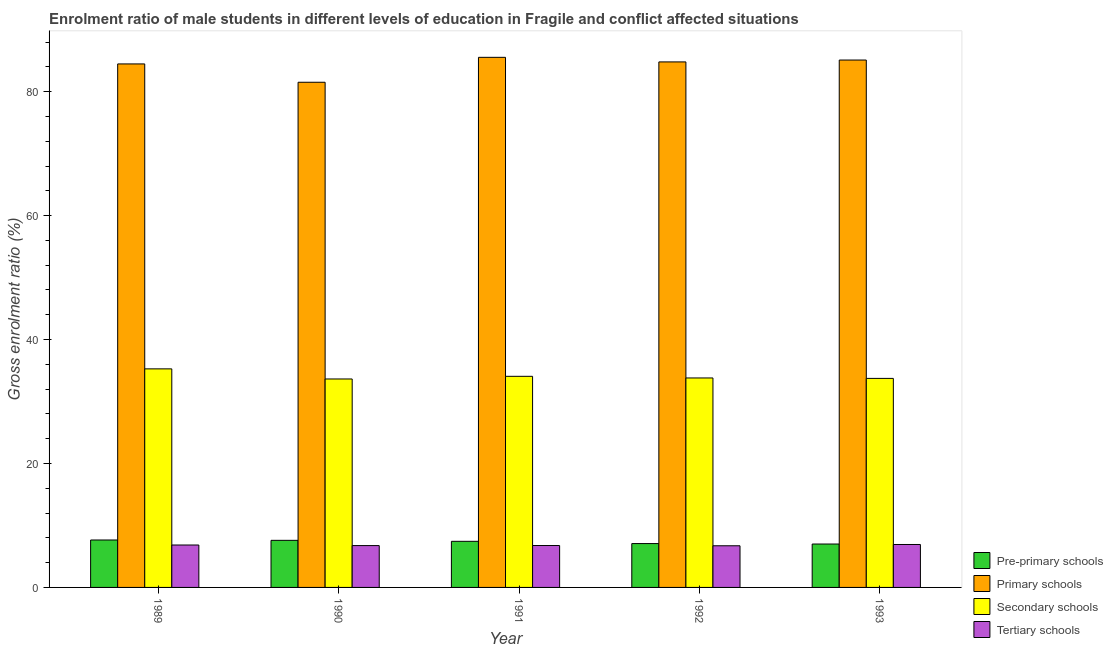How many different coloured bars are there?
Ensure brevity in your answer.  4. How many groups of bars are there?
Your answer should be compact. 5. Are the number of bars per tick equal to the number of legend labels?
Make the answer very short. Yes. Are the number of bars on each tick of the X-axis equal?
Make the answer very short. Yes. How many bars are there on the 2nd tick from the left?
Offer a terse response. 4. How many bars are there on the 1st tick from the right?
Your answer should be compact. 4. What is the label of the 4th group of bars from the left?
Provide a short and direct response. 1992. What is the gross enrolment ratio(female) in secondary schools in 1990?
Give a very brief answer. 33.64. Across all years, what is the maximum gross enrolment ratio(female) in pre-primary schools?
Your response must be concise. 7.65. Across all years, what is the minimum gross enrolment ratio(female) in primary schools?
Make the answer very short. 81.51. What is the total gross enrolment ratio(female) in primary schools in the graph?
Your answer should be very brief. 421.42. What is the difference between the gross enrolment ratio(female) in secondary schools in 1991 and that in 1992?
Offer a terse response. 0.26. What is the difference between the gross enrolment ratio(female) in secondary schools in 1992 and the gross enrolment ratio(female) in pre-primary schools in 1990?
Keep it short and to the point. 0.16. What is the average gross enrolment ratio(female) in secondary schools per year?
Offer a terse response. 34.1. What is the ratio of the gross enrolment ratio(female) in primary schools in 1990 to that in 1991?
Provide a succinct answer. 0.95. Is the gross enrolment ratio(female) in primary schools in 1990 less than that in 1992?
Ensure brevity in your answer.  Yes. What is the difference between the highest and the second highest gross enrolment ratio(female) in tertiary schools?
Your answer should be very brief. 0.08. What is the difference between the highest and the lowest gross enrolment ratio(female) in pre-primary schools?
Keep it short and to the point. 0.65. In how many years, is the gross enrolment ratio(female) in tertiary schools greater than the average gross enrolment ratio(female) in tertiary schools taken over all years?
Your response must be concise. 2. What does the 2nd bar from the left in 1992 represents?
Give a very brief answer. Primary schools. What does the 1st bar from the right in 1991 represents?
Keep it short and to the point. Tertiary schools. How many bars are there?
Give a very brief answer. 20. Are all the bars in the graph horizontal?
Provide a short and direct response. No. Does the graph contain any zero values?
Provide a succinct answer. No. Does the graph contain grids?
Provide a short and direct response. No. Where does the legend appear in the graph?
Offer a terse response. Bottom right. What is the title of the graph?
Your answer should be very brief. Enrolment ratio of male students in different levels of education in Fragile and conflict affected situations. What is the Gross enrolment ratio (%) of Pre-primary schools in 1989?
Your answer should be compact. 7.65. What is the Gross enrolment ratio (%) in Primary schools in 1989?
Your answer should be very brief. 84.47. What is the Gross enrolment ratio (%) in Secondary schools in 1989?
Ensure brevity in your answer.  35.27. What is the Gross enrolment ratio (%) of Tertiary schools in 1989?
Give a very brief answer. 6.84. What is the Gross enrolment ratio (%) in Pre-primary schools in 1990?
Give a very brief answer. 7.6. What is the Gross enrolment ratio (%) in Primary schools in 1990?
Offer a very short reply. 81.51. What is the Gross enrolment ratio (%) of Secondary schools in 1990?
Provide a succinct answer. 33.64. What is the Gross enrolment ratio (%) of Tertiary schools in 1990?
Offer a terse response. 6.75. What is the Gross enrolment ratio (%) of Pre-primary schools in 1991?
Provide a short and direct response. 7.44. What is the Gross enrolment ratio (%) in Primary schools in 1991?
Your answer should be compact. 85.54. What is the Gross enrolment ratio (%) of Secondary schools in 1991?
Make the answer very short. 34.06. What is the Gross enrolment ratio (%) of Tertiary schools in 1991?
Give a very brief answer. 6.76. What is the Gross enrolment ratio (%) of Pre-primary schools in 1992?
Offer a terse response. 7.08. What is the Gross enrolment ratio (%) in Primary schools in 1992?
Offer a terse response. 84.8. What is the Gross enrolment ratio (%) in Secondary schools in 1992?
Make the answer very short. 33.8. What is the Gross enrolment ratio (%) of Tertiary schools in 1992?
Provide a succinct answer. 6.72. What is the Gross enrolment ratio (%) in Pre-primary schools in 1993?
Your answer should be compact. 7. What is the Gross enrolment ratio (%) of Primary schools in 1993?
Give a very brief answer. 85.1. What is the Gross enrolment ratio (%) of Secondary schools in 1993?
Your response must be concise. 33.73. What is the Gross enrolment ratio (%) in Tertiary schools in 1993?
Your answer should be compact. 6.93. Across all years, what is the maximum Gross enrolment ratio (%) in Pre-primary schools?
Provide a succinct answer. 7.65. Across all years, what is the maximum Gross enrolment ratio (%) of Primary schools?
Make the answer very short. 85.54. Across all years, what is the maximum Gross enrolment ratio (%) in Secondary schools?
Make the answer very short. 35.27. Across all years, what is the maximum Gross enrolment ratio (%) in Tertiary schools?
Your response must be concise. 6.93. Across all years, what is the minimum Gross enrolment ratio (%) of Pre-primary schools?
Offer a very short reply. 7. Across all years, what is the minimum Gross enrolment ratio (%) of Primary schools?
Keep it short and to the point. 81.51. Across all years, what is the minimum Gross enrolment ratio (%) in Secondary schools?
Your answer should be compact. 33.64. Across all years, what is the minimum Gross enrolment ratio (%) in Tertiary schools?
Offer a terse response. 6.72. What is the total Gross enrolment ratio (%) in Pre-primary schools in the graph?
Your response must be concise. 36.77. What is the total Gross enrolment ratio (%) of Primary schools in the graph?
Offer a very short reply. 421.42. What is the total Gross enrolment ratio (%) of Secondary schools in the graph?
Offer a very short reply. 170.49. What is the total Gross enrolment ratio (%) in Tertiary schools in the graph?
Offer a very short reply. 34.01. What is the difference between the Gross enrolment ratio (%) in Pre-primary schools in 1989 and that in 1990?
Ensure brevity in your answer.  0.05. What is the difference between the Gross enrolment ratio (%) of Primary schools in 1989 and that in 1990?
Your answer should be very brief. 2.96. What is the difference between the Gross enrolment ratio (%) of Secondary schools in 1989 and that in 1990?
Provide a short and direct response. 1.63. What is the difference between the Gross enrolment ratio (%) in Tertiary schools in 1989 and that in 1990?
Offer a terse response. 0.09. What is the difference between the Gross enrolment ratio (%) of Pre-primary schools in 1989 and that in 1991?
Offer a very short reply. 0.22. What is the difference between the Gross enrolment ratio (%) in Primary schools in 1989 and that in 1991?
Provide a succinct answer. -1.06. What is the difference between the Gross enrolment ratio (%) of Secondary schools in 1989 and that in 1991?
Keep it short and to the point. 1.2. What is the difference between the Gross enrolment ratio (%) in Tertiary schools in 1989 and that in 1991?
Offer a very short reply. 0.08. What is the difference between the Gross enrolment ratio (%) of Pre-primary schools in 1989 and that in 1992?
Your response must be concise. 0.58. What is the difference between the Gross enrolment ratio (%) in Primary schools in 1989 and that in 1992?
Your response must be concise. -0.33. What is the difference between the Gross enrolment ratio (%) in Secondary schools in 1989 and that in 1992?
Offer a terse response. 1.47. What is the difference between the Gross enrolment ratio (%) in Tertiary schools in 1989 and that in 1992?
Your response must be concise. 0.12. What is the difference between the Gross enrolment ratio (%) of Pre-primary schools in 1989 and that in 1993?
Make the answer very short. 0.65. What is the difference between the Gross enrolment ratio (%) of Primary schools in 1989 and that in 1993?
Provide a short and direct response. -0.63. What is the difference between the Gross enrolment ratio (%) in Secondary schools in 1989 and that in 1993?
Give a very brief answer. 1.54. What is the difference between the Gross enrolment ratio (%) in Tertiary schools in 1989 and that in 1993?
Your answer should be very brief. -0.08. What is the difference between the Gross enrolment ratio (%) in Pre-primary schools in 1990 and that in 1991?
Keep it short and to the point. 0.16. What is the difference between the Gross enrolment ratio (%) of Primary schools in 1990 and that in 1991?
Provide a short and direct response. -4.02. What is the difference between the Gross enrolment ratio (%) in Secondary schools in 1990 and that in 1991?
Provide a short and direct response. -0.43. What is the difference between the Gross enrolment ratio (%) of Tertiary schools in 1990 and that in 1991?
Offer a terse response. -0.01. What is the difference between the Gross enrolment ratio (%) in Pre-primary schools in 1990 and that in 1992?
Ensure brevity in your answer.  0.52. What is the difference between the Gross enrolment ratio (%) in Primary schools in 1990 and that in 1992?
Ensure brevity in your answer.  -3.28. What is the difference between the Gross enrolment ratio (%) of Secondary schools in 1990 and that in 1992?
Provide a succinct answer. -0.16. What is the difference between the Gross enrolment ratio (%) in Tertiary schools in 1990 and that in 1992?
Your answer should be compact. 0.03. What is the difference between the Gross enrolment ratio (%) in Pre-primary schools in 1990 and that in 1993?
Make the answer very short. 0.6. What is the difference between the Gross enrolment ratio (%) of Primary schools in 1990 and that in 1993?
Provide a succinct answer. -3.58. What is the difference between the Gross enrolment ratio (%) in Secondary schools in 1990 and that in 1993?
Offer a terse response. -0.09. What is the difference between the Gross enrolment ratio (%) of Tertiary schools in 1990 and that in 1993?
Keep it short and to the point. -0.17. What is the difference between the Gross enrolment ratio (%) of Pre-primary schools in 1991 and that in 1992?
Keep it short and to the point. 0.36. What is the difference between the Gross enrolment ratio (%) of Primary schools in 1991 and that in 1992?
Keep it short and to the point. 0.74. What is the difference between the Gross enrolment ratio (%) of Secondary schools in 1991 and that in 1992?
Provide a short and direct response. 0.26. What is the difference between the Gross enrolment ratio (%) of Tertiary schools in 1991 and that in 1992?
Keep it short and to the point. 0.04. What is the difference between the Gross enrolment ratio (%) in Pre-primary schools in 1991 and that in 1993?
Provide a succinct answer. 0.44. What is the difference between the Gross enrolment ratio (%) in Primary schools in 1991 and that in 1993?
Your answer should be compact. 0.44. What is the difference between the Gross enrolment ratio (%) of Secondary schools in 1991 and that in 1993?
Your answer should be very brief. 0.34. What is the difference between the Gross enrolment ratio (%) in Tertiary schools in 1991 and that in 1993?
Offer a terse response. -0.17. What is the difference between the Gross enrolment ratio (%) of Pre-primary schools in 1992 and that in 1993?
Ensure brevity in your answer.  0.07. What is the difference between the Gross enrolment ratio (%) of Primary schools in 1992 and that in 1993?
Keep it short and to the point. -0.3. What is the difference between the Gross enrolment ratio (%) of Secondary schools in 1992 and that in 1993?
Keep it short and to the point. 0.07. What is the difference between the Gross enrolment ratio (%) in Tertiary schools in 1992 and that in 1993?
Provide a short and direct response. -0.21. What is the difference between the Gross enrolment ratio (%) in Pre-primary schools in 1989 and the Gross enrolment ratio (%) in Primary schools in 1990?
Your answer should be compact. -73.86. What is the difference between the Gross enrolment ratio (%) of Pre-primary schools in 1989 and the Gross enrolment ratio (%) of Secondary schools in 1990?
Your answer should be very brief. -25.98. What is the difference between the Gross enrolment ratio (%) of Pre-primary schools in 1989 and the Gross enrolment ratio (%) of Tertiary schools in 1990?
Offer a very short reply. 0.9. What is the difference between the Gross enrolment ratio (%) in Primary schools in 1989 and the Gross enrolment ratio (%) in Secondary schools in 1990?
Ensure brevity in your answer.  50.84. What is the difference between the Gross enrolment ratio (%) in Primary schools in 1989 and the Gross enrolment ratio (%) in Tertiary schools in 1990?
Ensure brevity in your answer.  77.72. What is the difference between the Gross enrolment ratio (%) of Secondary schools in 1989 and the Gross enrolment ratio (%) of Tertiary schools in 1990?
Ensure brevity in your answer.  28.51. What is the difference between the Gross enrolment ratio (%) in Pre-primary schools in 1989 and the Gross enrolment ratio (%) in Primary schools in 1991?
Make the answer very short. -77.88. What is the difference between the Gross enrolment ratio (%) in Pre-primary schools in 1989 and the Gross enrolment ratio (%) in Secondary schools in 1991?
Ensure brevity in your answer.  -26.41. What is the difference between the Gross enrolment ratio (%) in Pre-primary schools in 1989 and the Gross enrolment ratio (%) in Tertiary schools in 1991?
Your response must be concise. 0.89. What is the difference between the Gross enrolment ratio (%) of Primary schools in 1989 and the Gross enrolment ratio (%) of Secondary schools in 1991?
Offer a terse response. 50.41. What is the difference between the Gross enrolment ratio (%) of Primary schools in 1989 and the Gross enrolment ratio (%) of Tertiary schools in 1991?
Offer a terse response. 77.71. What is the difference between the Gross enrolment ratio (%) in Secondary schools in 1989 and the Gross enrolment ratio (%) in Tertiary schools in 1991?
Provide a short and direct response. 28.5. What is the difference between the Gross enrolment ratio (%) of Pre-primary schools in 1989 and the Gross enrolment ratio (%) of Primary schools in 1992?
Your answer should be compact. -77.14. What is the difference between the Gross enrolment ratio (%) in Pre-primary schools in 1989 and the Gross enrolment ratio (%) in Secondary schools in 1992?
Provide a succinct answer. -26.15. What is the difference between the Gross enrolment ratio (%) in Pre-primary schools in 1989 and the Gross enrolment ratio (%) in Tertiary schools in 1992?
Give a very brief answer. 0.93. What is the difference between the Gross enrolment ratio (%) in Primary schools in 1989 and the Gross enrolment ratio (%) in Secondary schools in 1992?
Give a very brief answer. 50.67. What is the difference between the Gross enrolment ratio (%) in Primary schools in 1989 and the Gross enrolment ratio (%) in Tertiary schools in 1992?
Offer a terse response. 77.75. What is the difference between the Gross enrolment ratio (%) of Secondary schools in 1989 and the Gross enrolment ratio (%) of Tertiary schools in 1992?
Give a very brief answer. 28.55. What is the difference between the Gross enrolment ratio (%) in Pre-primary schools in 1989 and the Gross enrolment ratio (%) in Primary schools in 1993?
Offer a terse response. -77.44. What is the difference between the Gross enrolment ratio (%) in Pre-primary schools in 1989 and the Gross enrolment ratio (%) in Secondary schools in 1993?
Provide a short and direct response. -26.07. What is the difference between the Gross enrolment ratio (%) of Pre-primary schools in 1989 and the Gross enrolment ratio (%) of Tertiary schools in 1993?
Your answer should be compact. 0.73. What is the difference between the Gross enrolment ratio (%) of Primary schools in 1989 and the Gross enrolment ratio (%) of Secondary schools in 1993?
Provide a succinct answer. 50.74. What is the difference between the Gross enrolment ratio (%) in Primary schools in 1989 and the Gross enrolment ratio (%) in Tertiary schools in 1993?
Make the answer very short. 77.54. What is the difference between the Gross enrolment ratio (%) of Secondary schools in 1989 and the Gross enrolment ratio (%) of Tertiary schools in 1993?
Your answer should be very brief. 28.34. What is the difference between the Gross enrolment ratio (%) in Pre-primary schools in 1990 and the Gross enrolment ratio (%) in Primary schools in 1991?
Offer a very short reply. -77.94. What is the difference between the Gross enrolment ratio (%) of Pre-primary schools in 1990 and the Gross enrolment ratio (%) of Secondary schools in 1991?
Keep it short and to the point. -26.46. What is the difference between the Gross enrolment ratio (%) in Pre-primary schools in 1990 and the Gross enrolment ratio (%) in Tertiary schools in 1991?
Offer a terse response. 0.84. What is the difference between the Gross enrolment ratio (%) of Primary schools in 1990 and the Gross enrolment ratio (%) of Secondary schools in 1991?
Ensure brevity in your answer.  47.45. What is the difference between the Gross enrolment ratio (%) of Primary schools in 1990 and the Gross enrolment ratio (%) of Tertiary schools in 1991?
Make the answer very short. 74.75. What is the difference between the Gross enrolment ratio (%) in Secondary schools in 1990 and the Gross enrolment ratio (%) in Tertiary schools in 1991?
Ensure brevity in your answer.  26.87. What is the difference between the Gross enrolment ratio (%) of Pre-primary schools in 1990 and the Gross enrolment ratio (%) of Primary schools in 1992?
Make the answer very short. -77.2. What is the difference between the Gross enrolment ratio (%) of Pre-primary schools in 1990 and the Gross enrolment ratio (%) of Secondary schools in 1992?
Your answer should be compact. -26.2. What is the difference between the Gross enrolment ratio (%) of Pre-primary schools in 1990 and the Gross enrolment ratio (%) of Tertiary schools in 1992?
Your response must be concise. 0.88. What is the difference between the Gross enrolment ratio (%) of Primary schools in 1990 and the Gross enrolment ratio (%) of Secondary schools in 1992?
Provide a short and direct response. 47.71. What is the difference between the Gross enrolment ratio (%) in Primary schools in 1990 and the Gross enrolment ratio (%) in Tertiary schools in 1992?
Give a very brief answer. 74.79. What is the difference between the Gross enrolment ratio (%) in Secondary schools in 1990 and the Gross enrolment ratio (%) in Tertiary schools in 1992?
Offer a very short reply. 26.92. What is the difference between the Gross enrolment ratio (%) of Pre-primary schools in 1990 and the Gross enrolment ratio (%) of Primary schools in 1993?
Give a very brief answer. -77.5. What is the difference between the Gross enrolment ratio (%) of Pre-primary schools in 1990 and the Gross enrolment ratio (%) of Secondary schools in 1993?
Your answer should be compact. -26.13. What is the difference between the Gross enrolment ratio (%) in Pre-primary schools in 1990 and the Gross enrolment ratio (%) in Tertiary schools in 1993?
Provide a succinct answer. 0.67. What is the difference between the Gross enrolment ratio (%) of Primary schools in 1990 and the Gross enrolment ratio (%) of Secondary schools in 1993?
Ensure brevity in your answer.  47.79. What is the difference between the Gross enrolment ratio (%) of Primary schools in 1990 and the Gross enrolment ratio (%) of Tertiary schools in 1993?
Offer a terse response. 74.59. What is the difference between the Gross enrolment ratio (%) in Secondary schools in 1990 and the Gross enrolment ratio (%) in Tertiary schools in 1993?
Ensure brevity in your answer.  26.71. What is the difference between the Gross enrolment ratio (%) in Pre-primary schools in 1991 and the Gross enrolment ratio (%) in Primary schools in 1992?
Your response must be concise. -77.36. What is the difference between the Gross enrolment ratio (%) of Pre-primary schools in 1991 and the Gross enrolment ratio (%) of Secondary schools in 1992?
Your answer should be compact. -26.36. What is the difference between the Gross enrolment ratio (%) in Pre-primary schools in 1991 and the Gross enrolment ratio (%) in Tertiary schools in 1992?
Give a very brief answer. 0.72. What is the difference between the Gross enrolment ratio (%) in Primary schools in 1991 and the Gross enrolment ratio (%) in Secondary schools in 1992?
Ensure brevity in your answer.  51.74. What is the difference between the Gross enrolment ratio (%) in Primary schools in 1991 and the Gross enrolment ratio (%) in Tertiary schools in 1992?
Give a very brief answer. 78.82. What is the difference between the Gross enrolment ratio (%) in Secondary schools in 1991 and the Gross enrolment ratio (%) in Tertiary schools in 1992?
Offer a very short reply. 27.34. What is the difference between the Gross enrolment ratio (%) of Pre-primary schools in 1991 and the Gross enrolment ratio (%) of Primary schools in 1993?
Provide a succinct answer. -77.66. What is the difference between the Gross enrolment ratio (%) in Pre-primary schools in 1991 and the Gross enrolment ratio (%) in Secondary schools in 1993?
Your response must be concise. -26.29. What is the difference between the Gross enrolment ratio (%) in Pre-primary schools in 1991 and the Gross enrolment ratio (%) in Tertiary schools in 1993?
Offer a very short reply. 0.51. What is the difference between the Gross enrolment ratio (%) of Primary schools in 1991 and the Gross enrolment ratio (%) of Secondary schools in 1993?
Provide a succinct answer. 51.81. What is the difference between the Gross enrolment ratio (%) in Primary schools in 1991 and the Gross enrolment ratio (%) in Tertiary schools in 1993?
Provide a short and direct response. 78.61. What is the difference between the Gross enrolment ratio (%) in Secondary schools in 1991 and the Gross enrolment ratio (%) in Tertiary schools in 1993?
Keep it short and to the point. 27.14. What is the difference between the Gross enrolment ratio (%) of Pre-primary schools in 1992 and the Gross enrolment ratio (%) of Primary schools in 1993?
Offer a very short reply. -78.02. What is the difference between the Gross enrolment ratio (%) of Pre-primary schools in 1992 and the Gross enrolment ratio (%) of Secondary schools in 1993?
Offer a terse response. -26.65. What is the difference between the Gross enrolment ratio (%) of Pre-primary schools in 1992 and the Gross enrolment ratio (%) of Tertiary schools in 1993?
Your answer should be compact. 0.15. What is the difference between the Gross enrolment ratio (%) of Primary schools in 1992 and the Gross enrolment ratio (%) of Secondary schools in 1993?
Your answer should be very brief. 51.07. What is the difference between the Gross enrolment ratio (%) in Primary schools in 1992 and the Gross enrolment ratio (%) in Tertiary schools in 1993?
Offer a terse response. 77.87. What is the difference between the Gross enrolment ratio (%) in Secondary schools in 1992 and the Gross enrolment ratio (%) in Tertiary schools in 1993?
Provide a short and direct response. 26.87. What is the average Gross enrolment ratio (%) of Pre-primary schools per year?
Provide a succinct answer. 7.35. What is the average Gross enrolment ratio (%) in Primary schools per year?
Provide a short and direct response. 84.28. What is the average Gross enrolment ratio (%) in Secondary schools per year?
Your response must be concise. 34.1. What is the average Gross enrolment ratio (%) of Tertiary schools per year?
Provide a short and direct response. 6.8. In the year 1989, what is the difference between the Gross enrolment ratio (%) of Pre-primary schools and Gross enrolment ratio (%) of Primary schools?
Provide a short and direct response. -76.82. In the year 1989, what is the difference between the Gross enrolment ratio (%) in Pre-primary schools and Gross enrolment ratio (%) in Secondary schools?
Your answer should be compact. -27.61. In the year 1989, what is the difference between the Gross enrolment ratio (%) in Pre-primary schools and Gross enrolment ratio (%) in Tertiary schools?
Keep it short and to the point. 0.81. In the year 1989, what is the difference between the Gross enrolment ratio (%) in Primary schools and Gross enrolment ratio (%) in Secondary schools?
Make the answer very short. 49.21. In the year 1989, what is the difference between the Gross enrolment ratio (%) in Primary schools and Gross enrolment ratio (%) in Tertiary schools?
Ensure brevity in your answer.  77.63. In the year 1989, what is the difference between the Gross enrolment ratio (%) in Secondary schools and Gross enrolment ratio (%) in Tertiary schools?
Your response must be concise. 28.42. In the year 1990, what is the difference between the Gross enrolment ratio (%) in Pre-primary schools and Gross enrolment ratio (%) in Primary schools?
Provide a succinct answer. -73.91. In the year 1990, what is the difference between the Gross enrolment ratio (%) in Pre-primary schools and Gross enrolment ratio (%) in Secondary schools?
Provide a short and direct response. -26.04. In the year 1990, what is the difference between the Gross enrolment ratio (%) in Pre-primary schools and Gross enrolment ratio (%) in Tertiary schools?
Ensure brevity in your answer.  0.85. In the year 1990, what is the difference between the Gross enrolment ratio (%) of Primary schools and Gross enrolment ratio (%) of Secondary schools?
Provide a succinct answer. 47.88. In the year 1990, what is the difference between the Gross enrolment ratio (%) in Primary schools and Gross enrolment ratio (%) in Tertiary schools?
Offer a terse response. 74.76. In the year 1990, what is the difference between the Gross enrolment ratio (%) in Secondary schools and Gross enrolment ratio (%) in Tertiary schools?
Provide a short and direct response. 26.88. In the year 1991, what is the difference between the Gross enrolment ratio (%) in Pre-primary schools and Gross enrolment ratio (%) in Primary schools?
Make the answer very short. -78.1. In the year 1991, what is the difference between the Gross enrolment ratio (%) of Pre-primary schools and Gross enrolment ratio (%) of Secondary schools?
Ensure brevity in your answer.  -26.63. In the year 1991, what is the difference between the Gross enrolment ratio (%) in Pre-primary schools and Gross enrolment ratio (%) in Tertiary schools?
Ensure brevity in your answer.  0.68. In the year 1991, what is the difference between the Gross enrolment ratio (%) in Primary schools and Gross enrolment ratio (%) in Secondary schools?
Make the answer very short. 51.47. In the year 1991, what is the difference between the Gross enrolment ratio (%) of Primary schools and Gross enrolment ratio (%) of Tertiary schools?
Ensure brevity in your answer.  78.77. In the year 1991, what is the difference between the Gross enrolment ratio (%) of Secondary schools and Gross enrolment ratio (%) of Tertiary schools?
Your answer should be compact. 27.3. In the year 1992, what is the difference between the Gross enrolment ratio (%) of Pre-primary schools and Gross enrolment ratio (%) of Primary schools?
Provide a short and direct response. -77.72. In the year 1992, what is the difference between the Gross enrolment ratio (%) of Pre-primary schools and Gross enrolment ratio (%) of Secondary schools?
Your answer should be compact. -26.72. In the year 1992, what is the difference between the Gross enrolment ratio (%) of Pre-primary schools and Gross enrolment ratio (%) of Tertiary schools?
Your response must be concise. 0.36. In the year 1992, what is the difference between the Gross enrolment ratio (%) of Primary schools and Gross enrolment ratio (%) of Secondary schools?
Provide a short and direct response. 51. In the year 1992, what is the difference between the Gross enrolment ratio (%) in Primary schools and Gross enrolment ratio (%) in Tertiary schools?
Your answer should be compact. 78.08. In the year 1992, what is the difference between the Gross enrolment ratio (%) in Secondary schools and Gross enrolment ratio (%) in Tertiary schools?
Ensure brevity in your answer.  27.08. In the year 1993, what is the difference between the Gross enrolment ratio (%) of Pre-primary schools and Gross enrolment ratio (%) of Primary schools?
Offer a very short reply. -78.09. In the year 1993, what is the difference between the Gross enrolment ratio (%) of Pre-primary schools and Gross enrolment ratio (%) of Secondary schools?
Your answer should be very brief. -26.73. In the year 1993, what is the difference between the Gross enrolment ratio (%) in Pre-primary schools and Gross enrolment ratio (%) in Tertiary schools?
Your answer should be compact. 0.08. In the year 1993, what is the difference between the Gross enrolment ratio (%) of Primary schools and Gross enrolment ratio (%) of Secondary schools?
Ensure brevity in your answer.  51.37. In the year 1993, what is the difference between the Gross enrolment ratio (%) in Primary schools and Gross enrolment ratio (%) in Tertiary schools?
Your response must be concise. 78.17. In the year 1993, what is the difference between the Gross enrolment ratio (%) of Secondary schools and Gross enrolment ratio (%) of Tertiary schools?
Keep it short and to the point. 26.8. What is the ratio of the Gross enrolment ratio (%) in Pre-primary schools in 1989 to that in 1990?
Make the answer very short. 1.01. What is the ratio of the Gross enrolment ratio (%) in Primary schools in 1989 to that in 1990?
Your answer should be compact. 1.04. What is the ratio of the Gross enrolment ratio (%) of Secondary schools in 1989 to that in 1990?
Provide a succinct answer. 1.05. What is the ratio of the Gross enrolment ratio (%) of Tertiary schools in 1989 to that in 1990?
Your answer should be very brief. 1.01. What is the ratio of the Gross enrolment ratio (%) in Pre-primary schools in 1989 to that in 1991?
Ensure brevity in your answer.  1.03. What is the ratio of the Gross enrolment ratio (%) of Primary schools in 1989 to that in 1991?
Offer a terse response. 0.99. What is the ratio of the Gross enrolment ratio (%) in Secondary schools in 1989 to that in 1991?
Offer a terse response. 1.04. What is the ratio of the Gross enrolment ratio (%) of Tertiary schools in 1989 to that in 1991?
Offer a very short reply. 1.01. What is the ratio of the Gross enrolment ratio (%) in Pre-primary schools in 1989 to that in 1992?
Give a very brief answer. 1.08. What is the ratio of the Gross enrolment ratio (%) in Secondary schools in 1989 to that in 1992?
Offer a very short reply. 1.04. What is the ratio of the Gross enrolment ratio (%) of Tertiary schools in 1989 to that in 1992?
Your answer should be very brief. 1.02. What is the ratio of the Gross enrolment ratio (%) of Pre-primary schools in 1989 to that in 1993?
Your response must be concise. 1.09. What is the ratio of the Gross enrolment ratio (%) in Secondary schools in 1989 to that in 1993?
Your response must be concise. 1.05. What is the ratio of the Gross enrolment ratio (%) in Tertiary schools in 1989 to that in 1993?
Give a very brief answer. 0.99. What is the ratio of the Gross enrolment ratio (%) of Pre-primary schools in 1990 to that in 1991?
Provide a short and direct response. 1.02. What is the ratio of the Gross enrolment ratio (%) of Primary schools in 1990 to that in 1991?
Your answer should be compact. 0.95. What is the ratio of the Gross enrolment ratio (%) in Secondary schools in 1990 to that in 1991?
Ensure brevity in your answer.  0.99. What is the ratio of the Gross enrolment ratio (%) in Tertiary schools in 1990 to that in 1991?
Give a very brief answer. 1. What is the ratio of the Gross enrolment ratio (%) in Pre-primary schools in 1990 to that in 1992?
Ensure brevity in your answer.  1.07. What is the ratio of the Gross enrolment ratio (%) in Primary schools in 1990 to that in 1992?
Your answer should be compact. 0.96. What is the ratio of the Gross enrolment ratio (%) of Pre-primary schools in 1990 to that in 1993?
Give a very brief answer. 1.09. What is the ratio of the Gross enrolment ratio (%) of Primary schools in 1990 to that in 1993?
Offer a terse response. 0.96. What is the ratio of the Gross enrolment ratio (%) in Secondary schools in 1990 to that in 1993?
Your answer should be compact. 1. What is the ratio of the Gross enrolment ratio (%) of Tertiary schools in 1990 to that in 1993?
Give a very brief answer. 0.97. What is the ratio of the Gross enrolment ratio (%) of Pre-primary schools in 1991 to that in 1992?
Your answer should be compact. 1.05. What is the ratio of the Gross enrolment ratio (%) of Primary schools in 1991 to that in 1992?
Your answer should be very brief. 1.01. What is the ratio of the Gross enrolment ratio (%) of Pre-primary schools in 1991 to that in 1993?
Offer a terse response. 1.06. What is the ratio of the Gross enrolment ratio (%) in Secondary schools in 1991 to that in 1993?
Keep it short and to the point. 1.01. What is the ratio of the Gross enrolment ratio (%) of Tertiary schools in 1991 to that in 1993?
Provide a short and direct response. 0.98. What is the ratio of the Gross enrolment ratio (%) of Pre-primary schools in 1992 to that in 1993?
Keep it short and to the point. 1.01. What is the ratio of the Gross enrolment ratio (%) in Primary schools in 1992 to that in 1993?
Give a very brief answer. 1. What is the ratio of the Gross enrolment ratio (%) of Tertiary schools in 1992 to that in 1993?
Provide a succinct answer. 0.97. What is the difference between the highest and the second highest Gross enrolment ratio (%) in Pre-primary schools?
Offer a very short reply. 0.05. What is the difference between the highest and the second highest Gross enrolment ratio (%) of Primary schools?
Your answer should be compact. 0.44. What is the difference between the highest and the second highest Gross enrolment ratio (%) of Secondary schools?
Your answer should be compact. 1.2. What is the difference between the highest and the second highest Gross enrolment ratio (%) in Tertiary schools?
Keep it short and to the point. 0.08. What is the difference between the highest and the lowest Gross enrolment ratio (%) of Pre-primary schools?
Keep it short and to the point. 0.65. What is the difference between the highest and the lowest Gross enrolment ratio (%) in Primary schools?
Your answer should be very brief. 4.02. What is the difference between the highest and the lowest Gross enrolment ratio (%) in Secondary schools?
Provide a succinct answer. 1.63. What is the difference between the highest and the lowest Gross enrolment ratio (%) of Tertiary schools?
Make the answer very short. 0.21. 